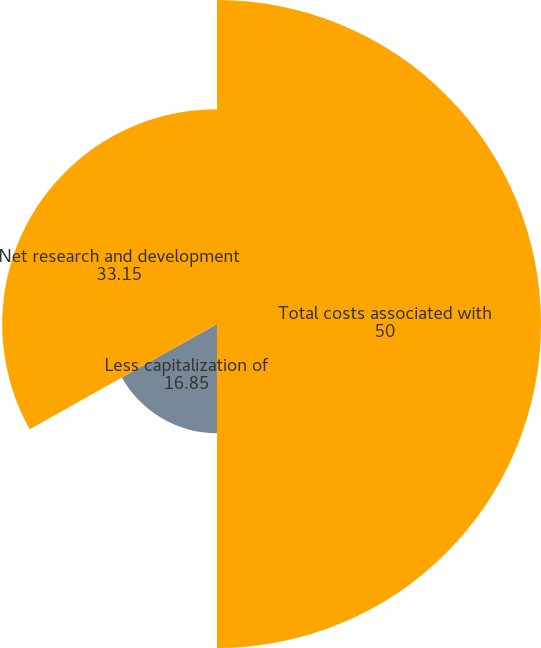Convert chart to OTSL. <chart><loc_0><loc_0><loc_500><loc_500><pie_chart><fcel>Total costs associated with<fcel>Less capitalization of<fcel>Net research and development<nl><fcel>50.0%<fcel>16.85%<fcel>33.15%<nl></chart> 